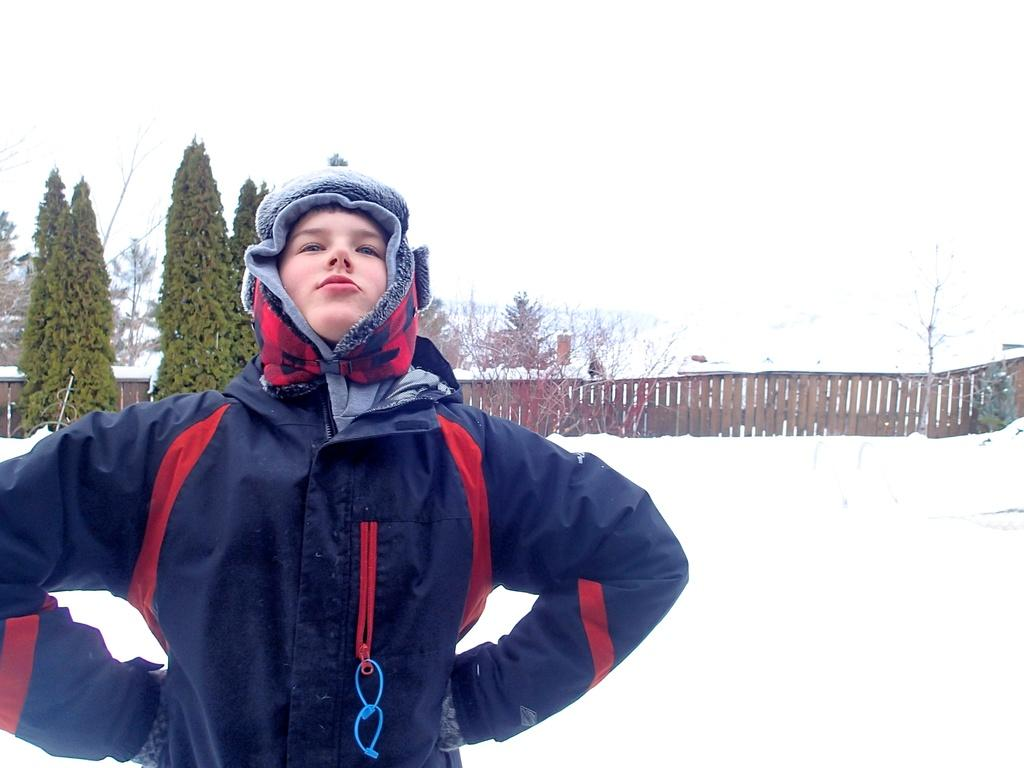What is the main subject of the image? There is a person standing in the image. What is the condition of the ice in the image? There is ice in the image. What type of fencing can be seen in the image? There is a wooden fencing in the image. How is the wooden fencing depicted in the image? The wooden fencing appears to be truncated. What type of vegetation is present in the image? There are trees in the image. What is the color of the background in the image? The background of the image is white in color. What is the value of the dress worn by the person in the image? There is no dress present in the image, so it is not possible to determine its value. 